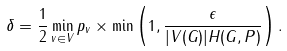<formula> <loc_0><loc_0><loc_500><loc_500>\delta = \frac { 1 } { 2 } \min _ { v \in V } p _ { v } \times \min \left ( 1 , \frac { \epsilon } { | V ( G ) | H ( G , P ) } \right ) .</formula> 